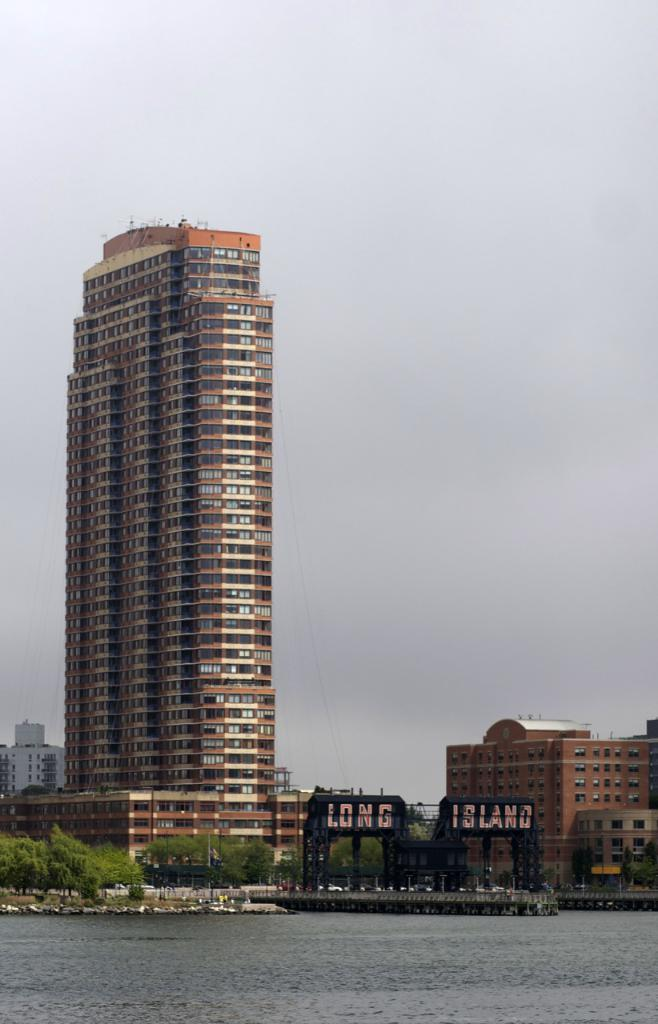What type of structures can be seen in the image? There are buildings in the image. What natural elements are present in the image? There are trees and water visible in the image. What other objects can be seen in the image besides buildings and trees? There are other objects in the image. What can be seen in the background of the image? The sky is visible in the background of the image. Can you see a twig in the image? There is no mention of a twig in the provided facts, so it cannot be confirmed whether a twig is present in the image. What is the head of the person doing in the image? There is no person or head visible in the image, so this question cannot be answered. 